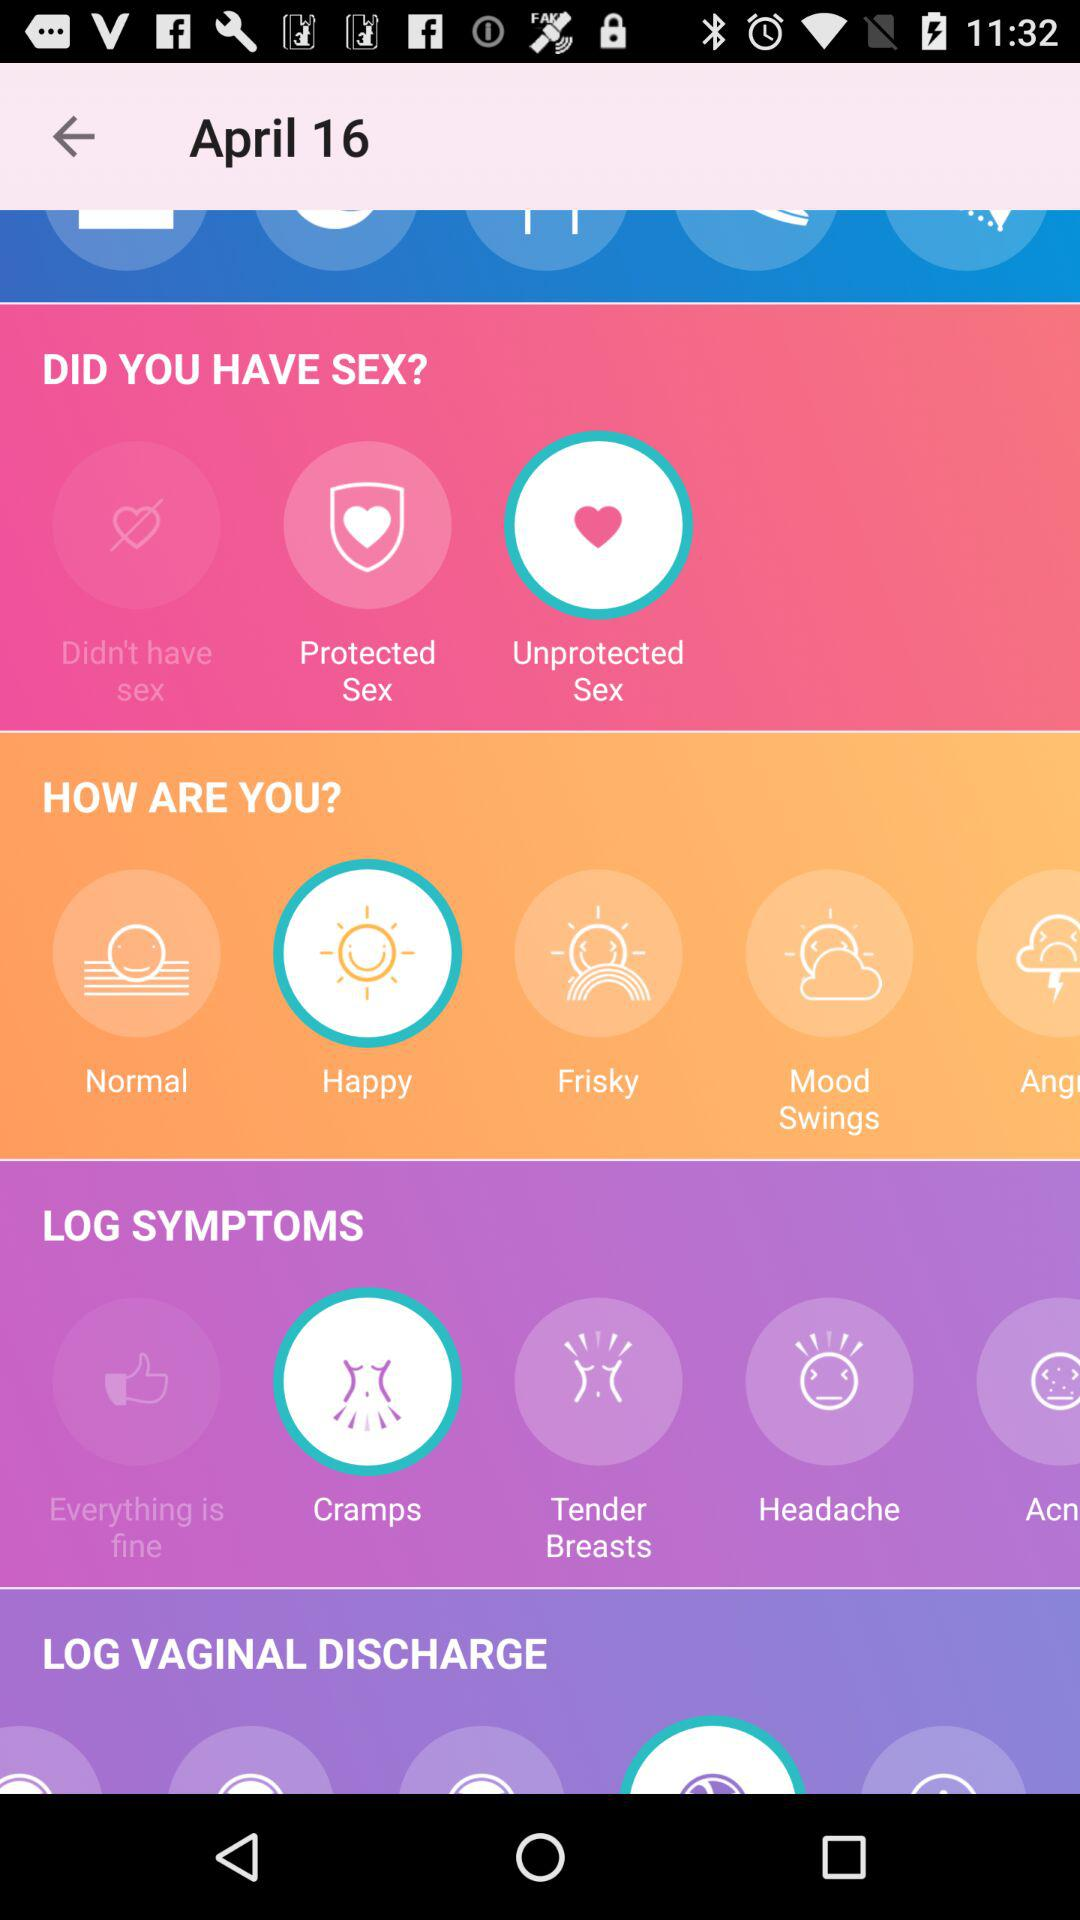What option is selected in "HOW ARE YOU?"? The selected option is "Happy". 